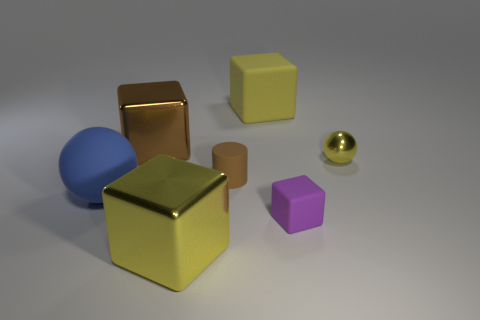Add 2 large shiny things. How many objects exist? 9 Subtract all cubes. How many objects are left? 3 Add 6 tiny yellow metal objects. How many tiny yellow metal objects are left? 7 Add 5 big metal cylinders. How many big metal cylinders exist? 5 Subtract 0 brown balls. How many objects are left? 7 Subtract all yellow rubber objects. Subtract all big brown cubes. How many objects are left? 5 